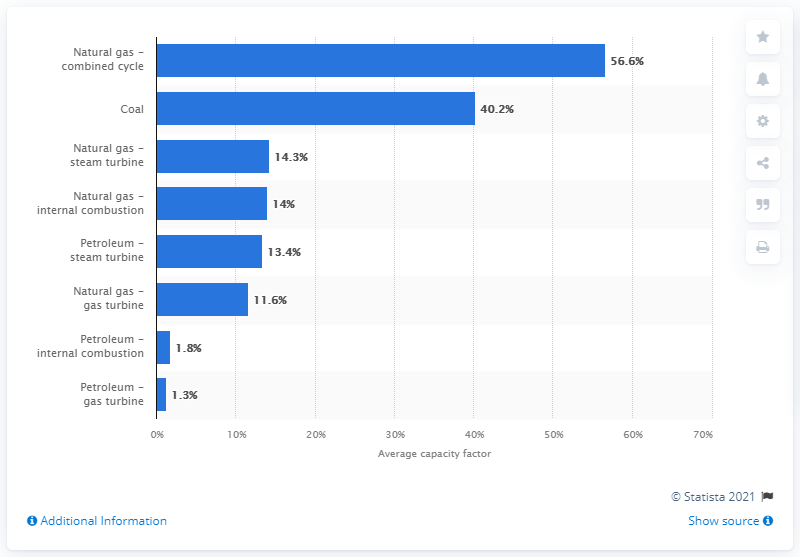Outline some significant characteristics in this image. The capacity factor of coal in 1992 was 40.2%. This indicates that coal plants operated at an average utilization rate of 40.2% during the year. The capacity factor of natural gas combined cycle generators was 56.6%. The capacity factor of a petroleum gas turbine was 1.3, indicating that it was operating at a high level of efficiency. 